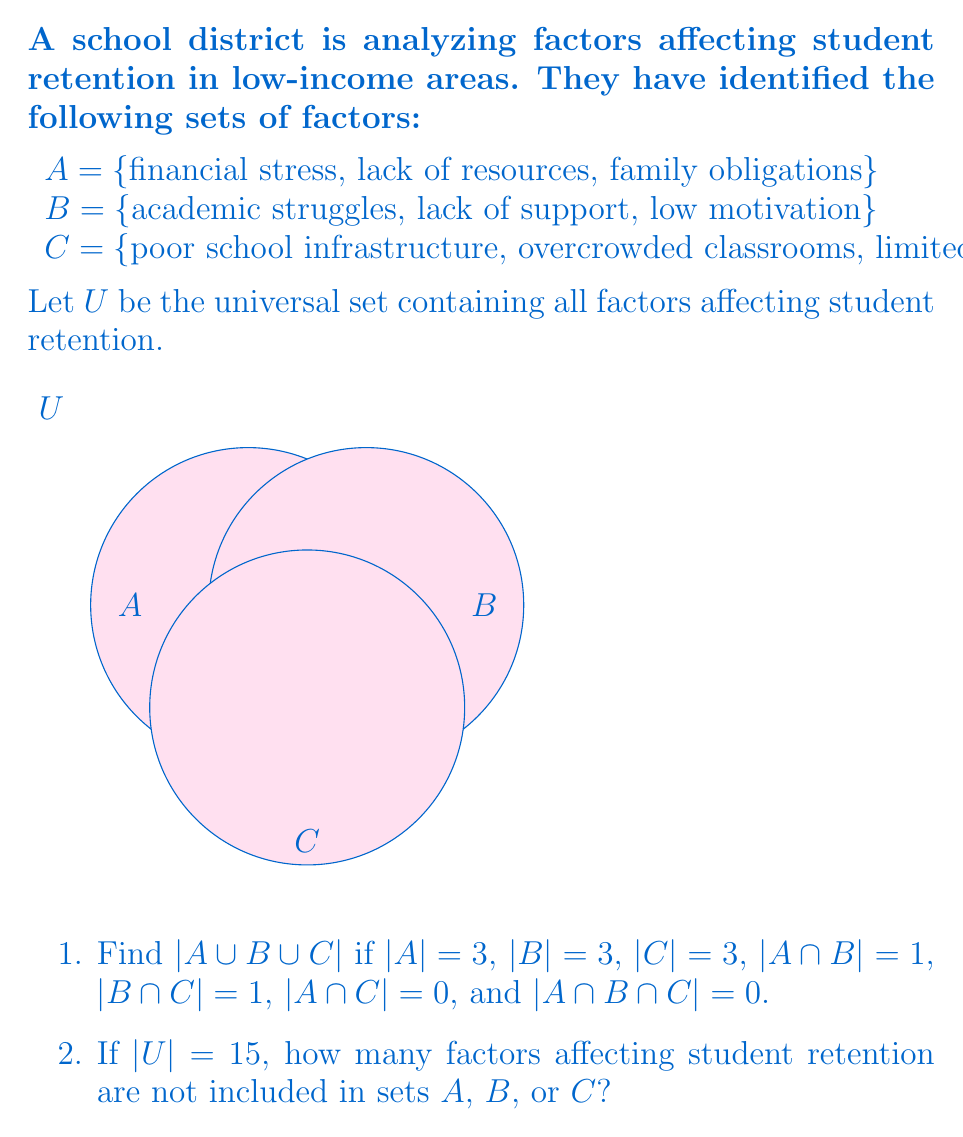Teach me how to tackle this problem. Let's approach this problem step-by-step using set theory:

1. To find $|A \cup B \cup C|$, we can use the Inclusion-Exclusion Principle:

   $|A \cup B \cup C| = |A| + |B| + |C| - |A \cap B| - |B \cap C| - |A \cap C| + |A \cap B \cap C|$

   Substituting the given values:
   $|A \cup B \cup C| = 3 + 3 + 3 - 1 - 1 - 0 + 0 = 7$

2. To find the number of factors not included in A, B, or C:

   Let X be the set of factors not in A, B, or C.
   Then, $U = (A \cup B \cup C) \cup X$, where $(A \cup B \cup C)$ and X are disjoint.

   Therefore, $|U| = |A \cup B \cup C| + |X|$
   
   We know that $|U| = 15$ and we calculated $|A \cup B \cup C| = 7$

   So, $15 = 7 + |X|$
   $|X| = 15 - 7 = 8$

Thus, there are 8 factors affecting student retention that are not included in sets A, B, or C.
Answer: 1) 7
2) 8 